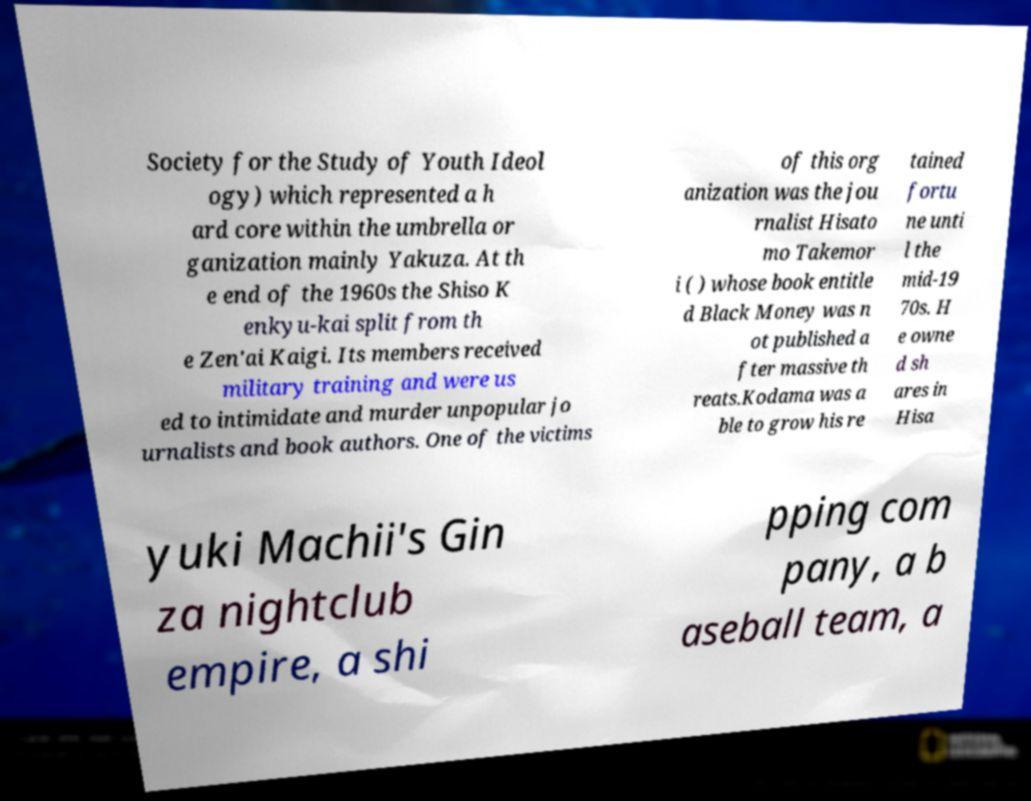Can you accurately transcribe the text from the provided image for me? Society for the Study of Youth Ideol ogy) which represented a h ard core within the umbrella or ganization mainly Yakuza. At th e end of the 1960s the Shiso K enkyu-kai split from th e Zen'ai Kaigi. Its members received military training and were us ed to intimidate and murder unpopular jo urnalists and book authors. One of the victims of this org anization was the jou rnalist Hisato mo Takemor i ( ) whose book entitle d Black Money was n ot published a fter massive th reats.Kodama was a ble to grow his re tained fortu ne unti l the mid-19 70s. H e owne d sh ares in Hisa yuki Machii's Gin za nightclub empire, a shi pping com pany, a b aseball team, a 